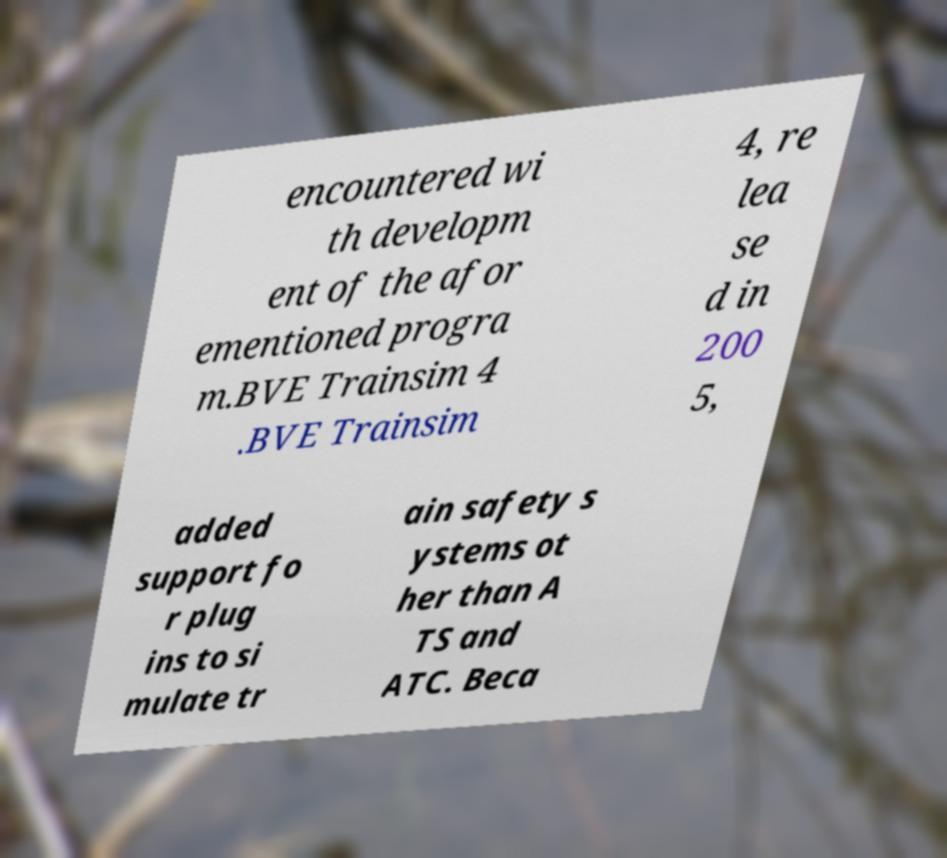I need the written content from this picture converted into text. Can you do that? encountered wi th developm ent of the afor ementioned progra m.BVE Trainsim 4 .BVE Trainsim 4, re lea se d in 200 5, added support fo r plug ins to si mulate tr ain safety s ystems ot her than A TS and ATC. Beca 